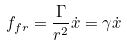Convert formula to latex. <formula><loc_0><loc_0><loc_500><loc_500>f _ { f r } = \frac { \Gamma } { r ^ { 2 } } \dot { x } = \gamma \dot { x }</formula> 